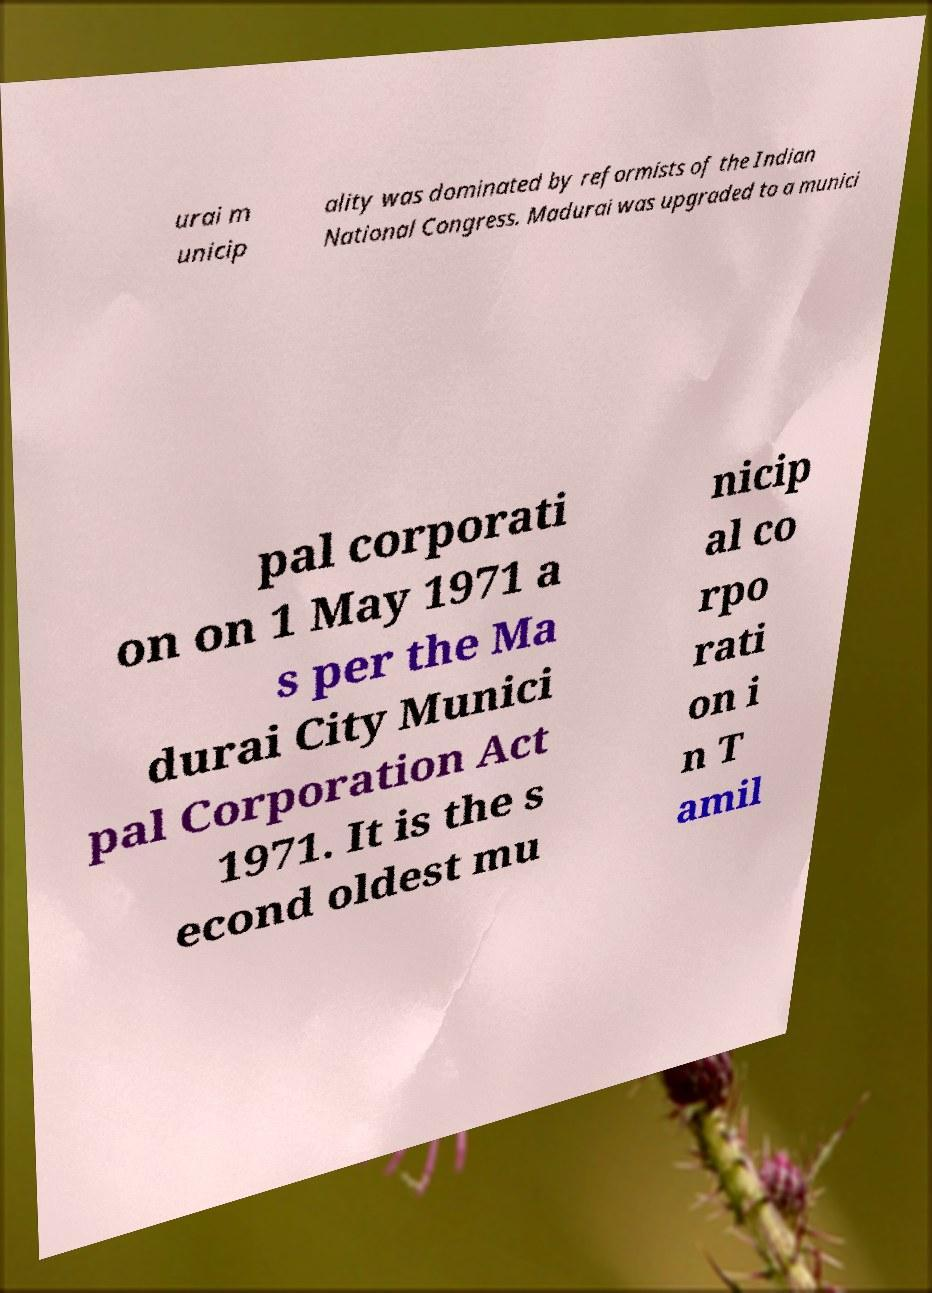What messages or text are displayed in this image? I need them in a readable, typed format. urai m unicip ality was dominated by reformists of the Indian National Congress. Madurai was upgraded to a munici pal corporati on on 1 May 1971 a s per the Ma durai City Munici pal Corporation Act 1971. It is the s econd oldest mu nicip al co rpo rati on i n T amil 